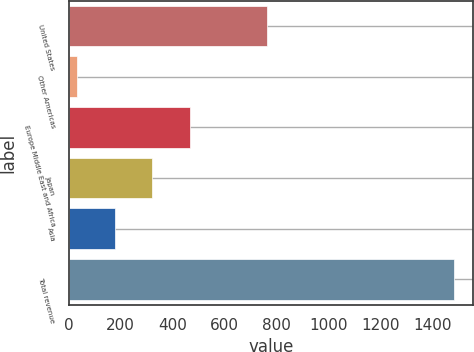Convert chart to OTSL. <chart><loc_0><loc_0><loc_500><loc_500><bar_chart><fcel>United States<fcel>Other Americas<fcel>Europe Middle East and Africa<fcel>Japan<fcel>Asia<fcel>Total revenue<nl><fcel>765.1<fcel>31.3<fcel>467.08<fcel>321.82<fcel>176.56<fcel>1483.9<nl></chart> 